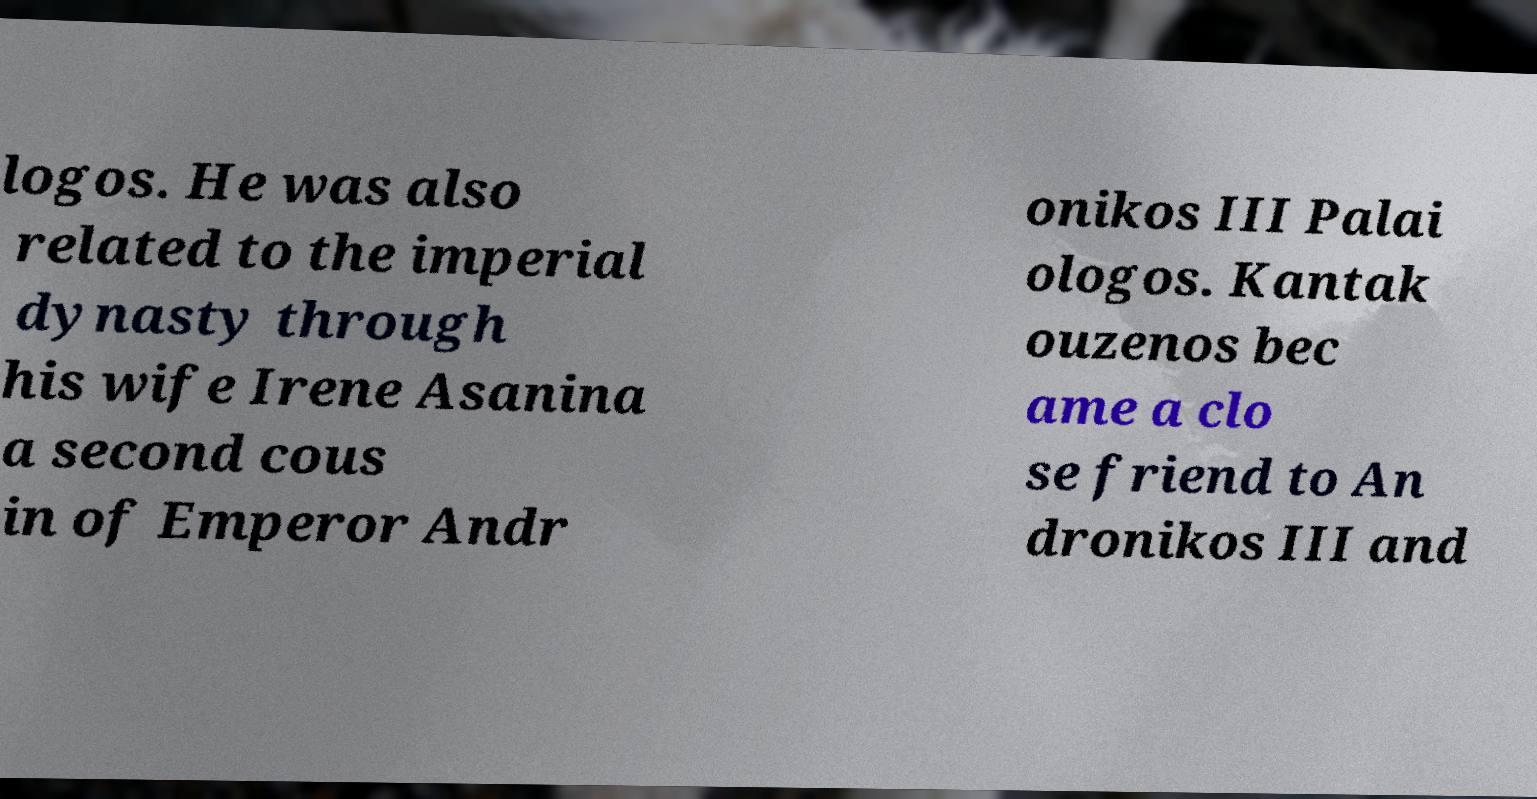Could you extract and type out the text from this image? logos. He was also related to the imperial dynasty through his wife Irene Asanina a second cous in of Emperor Andr onikos III Palai ologos. Kantak ouzenos bec ame a clo se friend to An dronikos III and 